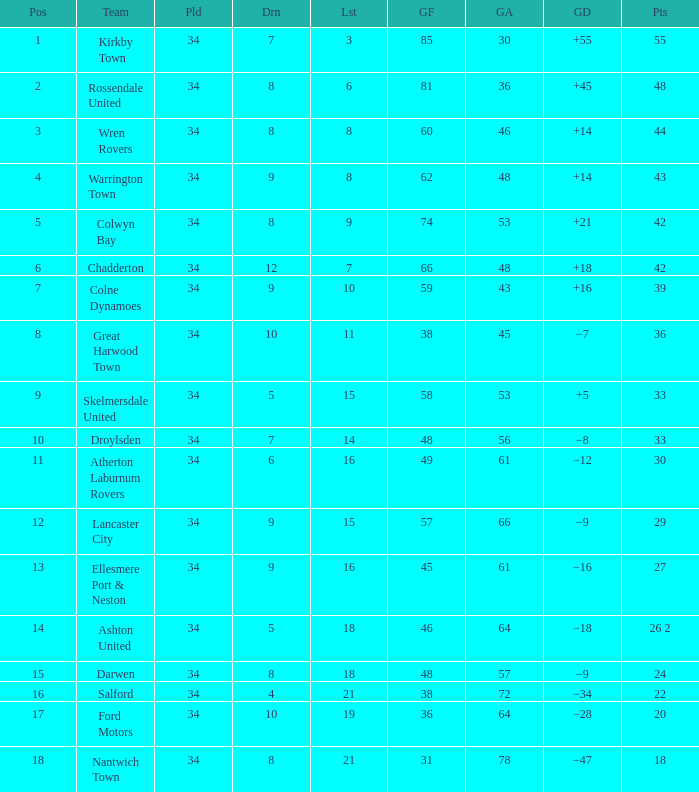What is the total number of positions when there are more than 48 goals against, 1 of 29 points are played, and less than 34 games have been played? 0.0. 